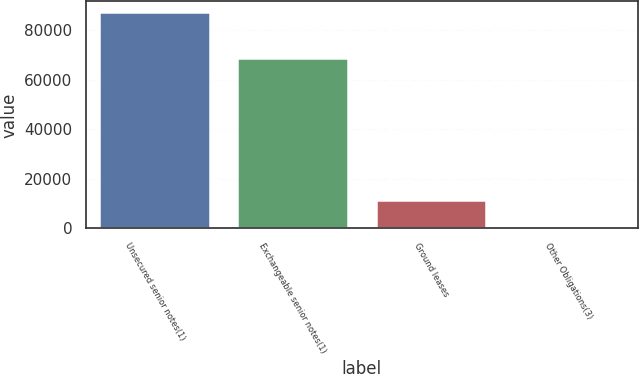Convert chart to OTSL. <chart><loc_0><loc_0><loc_500><loc_500><bar_chart><fcel>Unsecured senior notes(1)<fcel>Exchangeable senior notes(1)<fcel>Ground leases<fcel>Other Obligations(3)<nl><fcel>87188<fcel>68769<fcel>11471<fcel>116<nl></chart> 